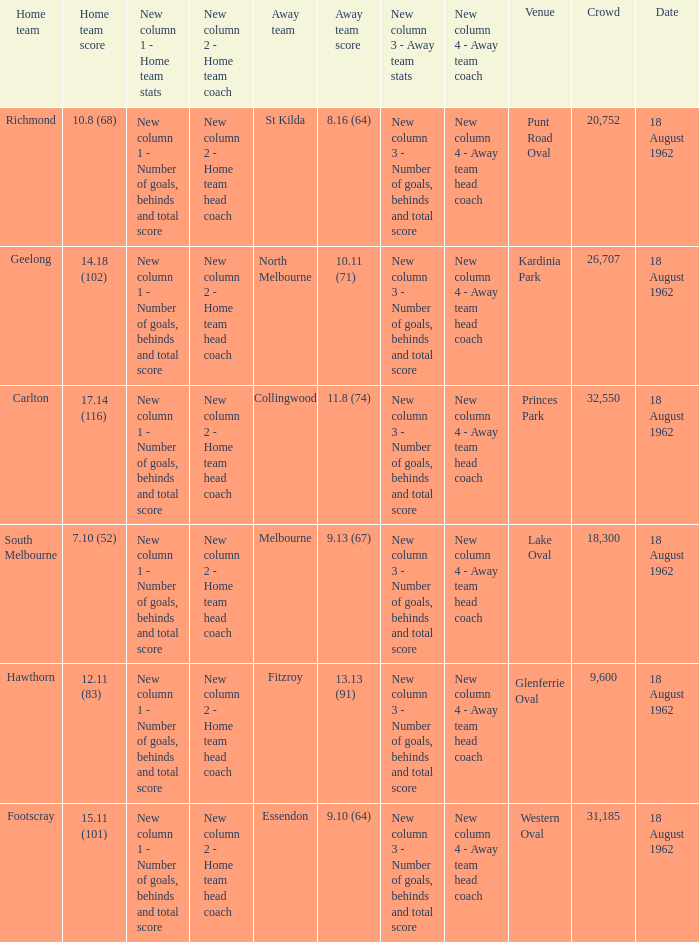What was the home team when the away team scored 9.10 (64)? Footscray. 